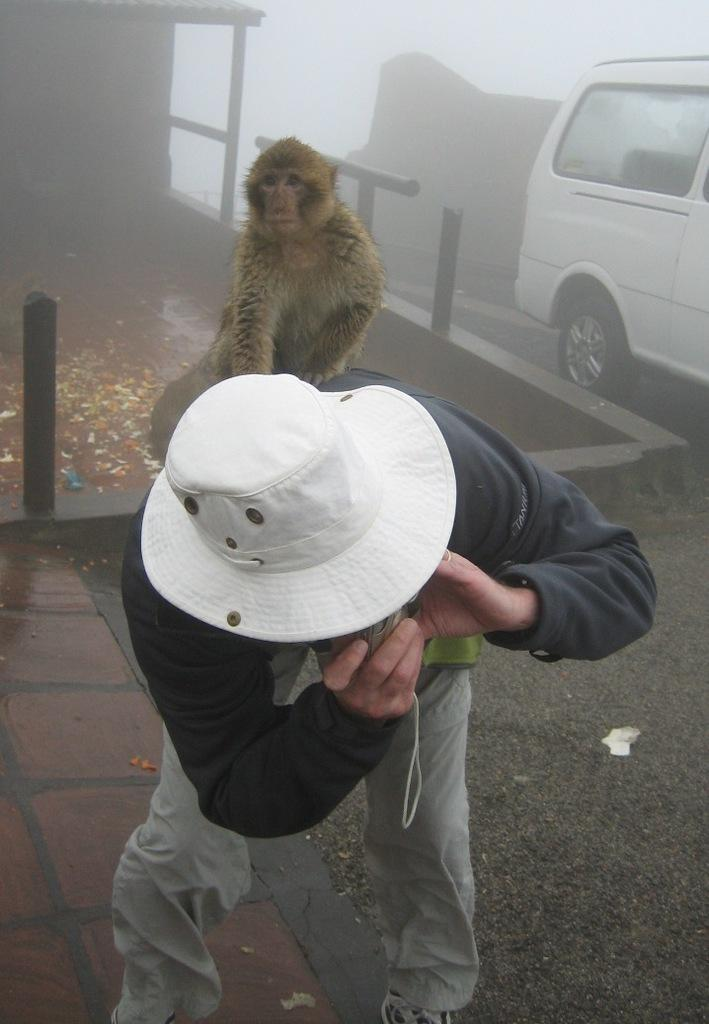What vehicle is located on the right side of the image? There is a car on the right side of the image. Who or what is in the middle of the image? There is a person in the middle of the image. What is the person holding? The person is holding a camera. What type of hat is the person wearing? The person is wearing a white hat. What animal is sitting on the person? A monkey is sitting on the person. What is the name of the owner of the territory in the image? There is no mention of an owner or territory in the image. How does the moon appear in the image? The moon is not present in the image. 